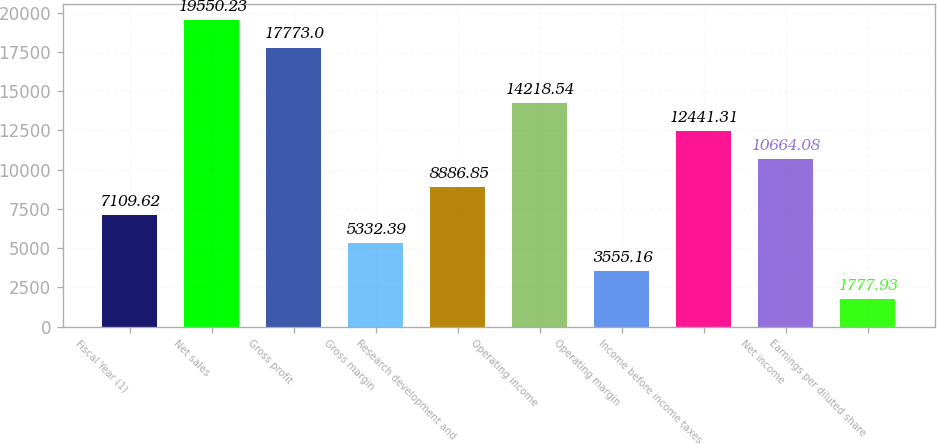<chart> <loc_0><loc_0><loc_500><loc_500><bar_chart><fcel>Fiscal Year (1)<fcel>Net sales<fcel>Gross profit<fcel>Gross margin<fcel>Research development and<fcel>Operating income<fcel>Operating margin<fcel>Income before income taxes<fcel>Net income<fcel>Earnings per diluted share<nl><fcel>7109.62<fcel>19550.2<fcel>17773<fcel>5332.39<fcel>8886.85<fcel>14218.5<fcel>3555.16<fcel>12441.3<fcel>10664.1<fcel>1777.93<nl></chart> 